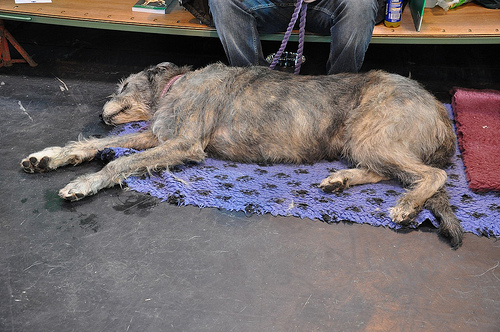<image>
Is the dog on the mat? Yes. Looking at the image, I can see the dog is positioned on top of the mat, with the mat providing support. Where is the dog in relation to the blanket? Is it behind the blanket? No. The dog is not behind the blanket. From this viewpoint, the dog appears to be positioned elsewhere in the scene. Is the dog in the blanket? No. The dog is not contained within the blanket. These objects have a different spatial relationship. 